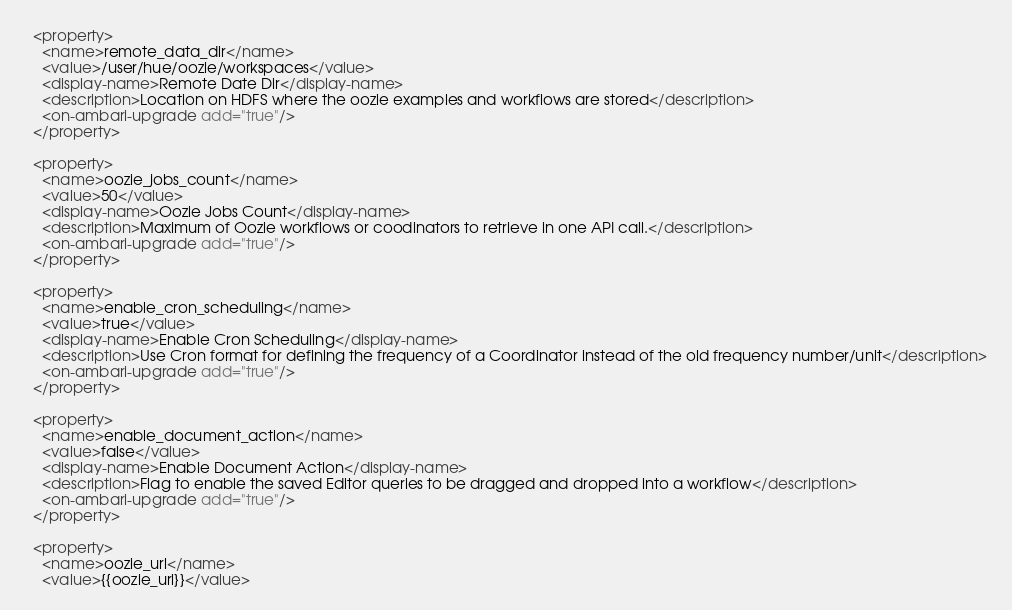Convert code to text. <code><loc_0><loc_0><loc_500><loc_500><_XML_>  <property>
    <name>remote_data_dir</name>
    <value>/user/hue/oozie/workspaces</value>
    <display-name>Remote Date Dir</display-name>
    <description>Location on HDFS where the oozie examples and workflows are stored</description>
    <on-ambari-upgrade add="true"/>
  </property>

  <property>
    <name>oozie_jobs_count</name>
    <value>50</value>
    <display-name>Oozie Jobs Count</display-name>
    <description>Maximum of Oozie workflows or coodinators to retrieve in one API call.</description>
    <on-ambari-upgrade add="true"/>
  </property>

  <property>
    <name>enable_cron_scheduling</name>
    <value>true</value>
    <display-name>Enable Cron Scheduling</display-name>
    <description>Use Cron format for defining the frequency of a Coordinator instead of the old frequency number/unit</description>
    <on-ambari-upgrade add="true"/>
  </property>

  <property>
    <name>enable_document_action</name>
    <value>false</value>
    <display-name>Enable Document Action</display-name>
    <description>Flag to enable the saved Editor queries to be dragged and dropped into a workflow</description>
    <on-ambari-upgrade add="true"/>
  </property>

  <property>
    <name>oozie_url</name>
    <value>{{oozie_url}}</value></code> 